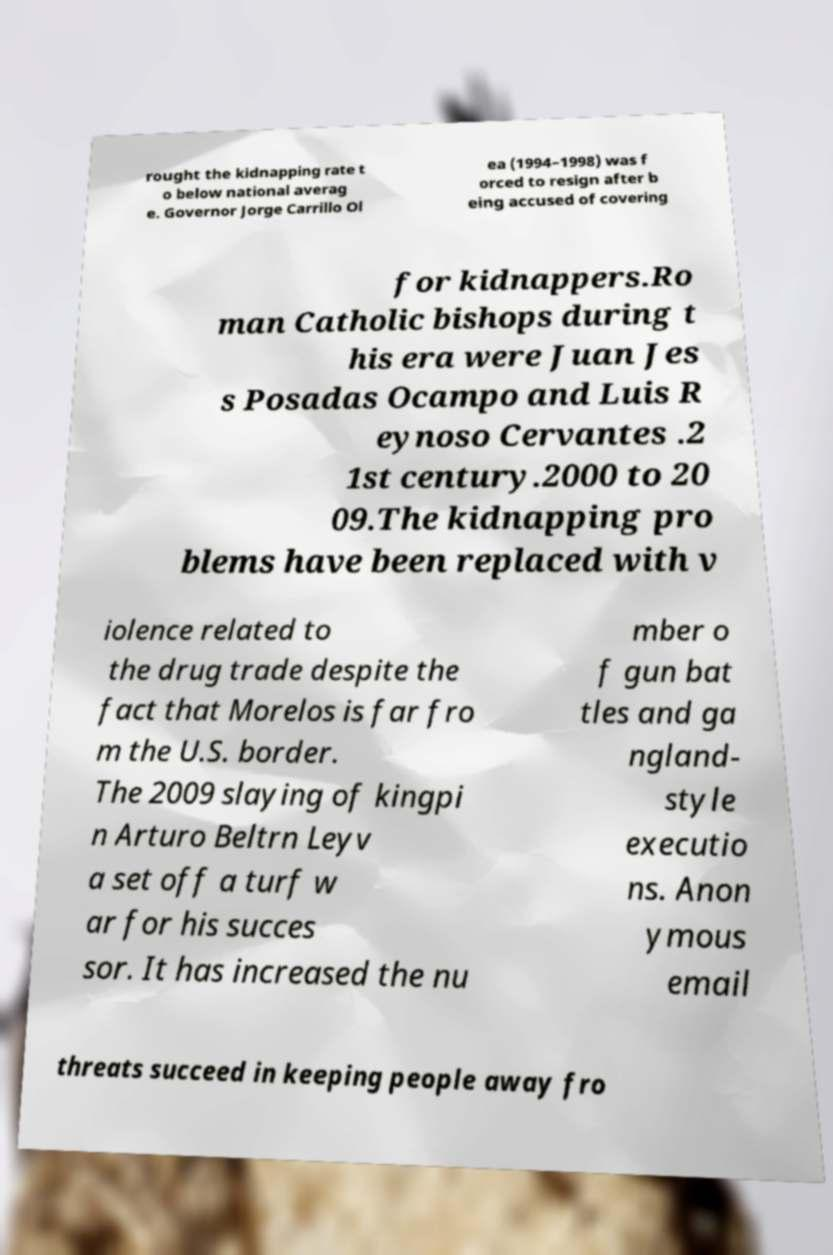Please read and relay the text visible in this image. What does it say? rought the kidnapping rate t o below national averag e. Governor Jorge Carrillo Ol ea (1994–1998) was f orced to resign after b eing accused of covering for kidnappers.Ro man Catholic bishops during t his era were Juan Jes s Posadas Ocampo and Luis R eynoso Cervantes .2 1st century.2000 to 20 09.The kidnapping pro blems have been replaced with v iolence related to the drug trade despite the fact that Morelos is far fro m the U.S. border. The 2009 slaying of kingpi n Arturo Beltrn Leyv a set off a turf w ar for his succes sor. It has increased the nu mber o f gun bat tles and ga ngland- style executio ns. Anon ymous email threats succeed in keeping people away fro 